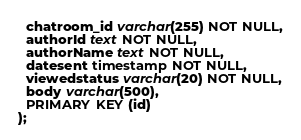<code> <loc_0><loc_0><loc_500><loc_500><_SQL_>  chatroom_id varchar(255) NOT NULL,
  authorId text NOT NULL,
  authorName text NOT NULL,
  datesent timestamp NOT NULL,
  viewedstatus varchar(20) NOT NULL,
  body varchar(500),
  PRIMARY KEY (id)
);</code> 